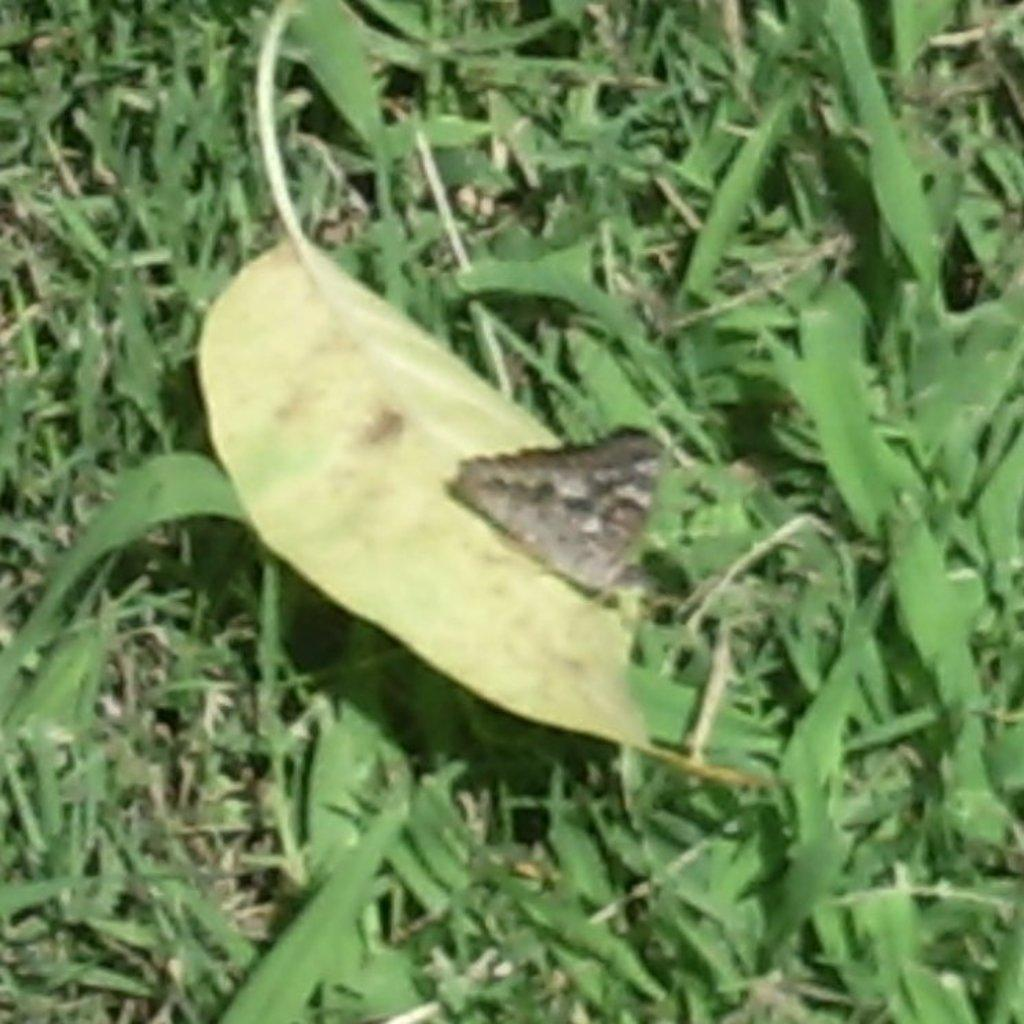What type of small creature can be seen in the image? There is an insect in the image. What type of plant material is visible in the image? There is a leaf and grass in the image. How does the insect increase the temperature of the image? The insect does not have the ability to increase the temperature of the image; it is a static element in the image. What type of creature is shown biting the leaf in the image? There is no creature shown biting the leaf in the image; only the insect, leaf, and grass are present. 